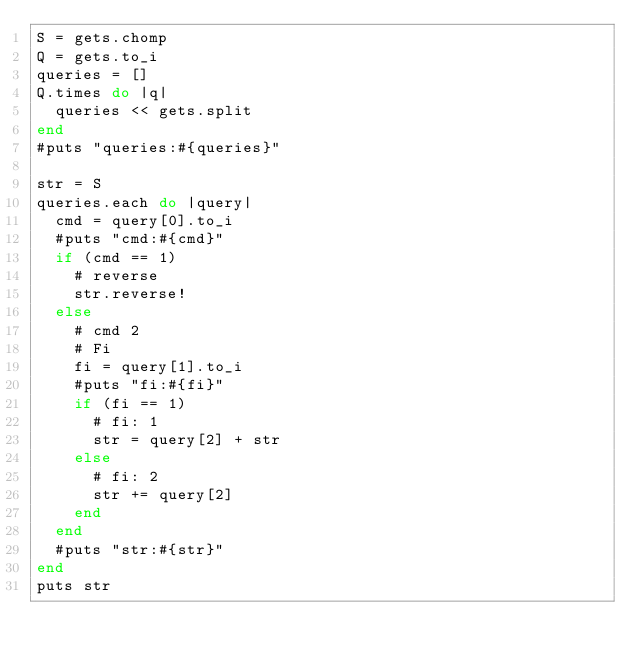<code> <loc_0><loc_0><loc_500><loc_500><_Ruby_>S = gets.chomp
Q = gets.to_i
queries = []
Q.times do |q|
  queries << gets.split
end
#puts "queries:#{queries}"

str = S
queries.each do |query|
  cmd = query[0].to_i
  #puts "cmd:#{cmd}"
  if (cmd == 1)
    # reverse
    str.reverse!
  else
    # cmd 2
    # Fi
    fi = query[1].to_i
    #puts "fi:#{fi}"
    if (fi == 1)
      # fi: 1
      str = query[2] + str
    else
      # fi: 2
      str += query[2]
    end
  end
  #puts "str:#{str}"
end
puts str

</code> 